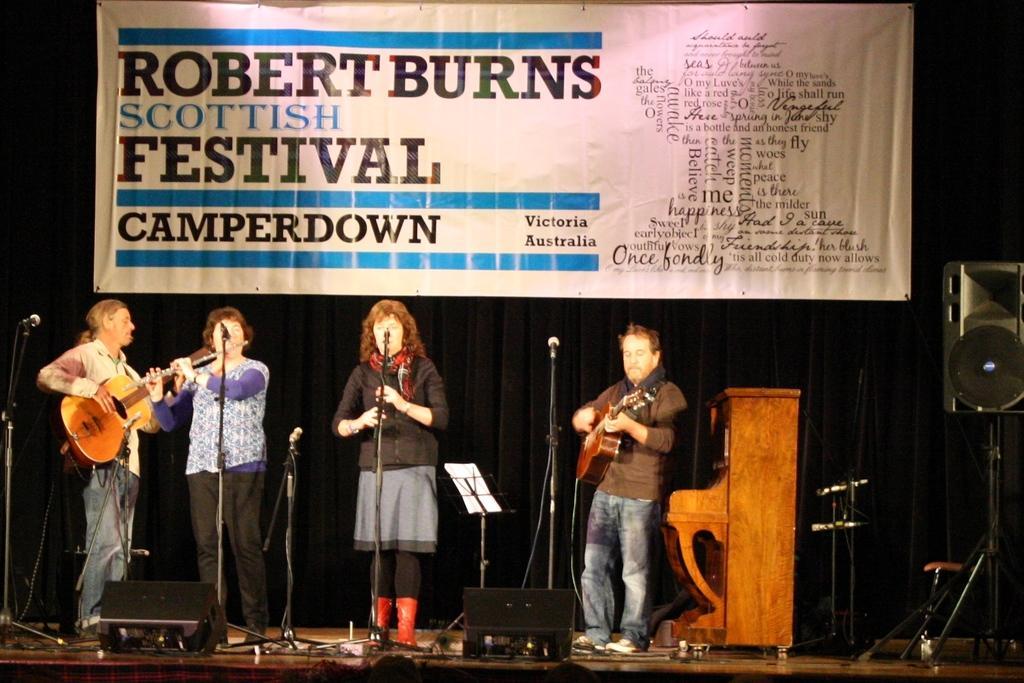Could you give a brief overview of what you see in this image? In this picture we can see four persons standing on stage where two are playing guitar and two are singing on mic and and in background we can see banner, speakers, table. 